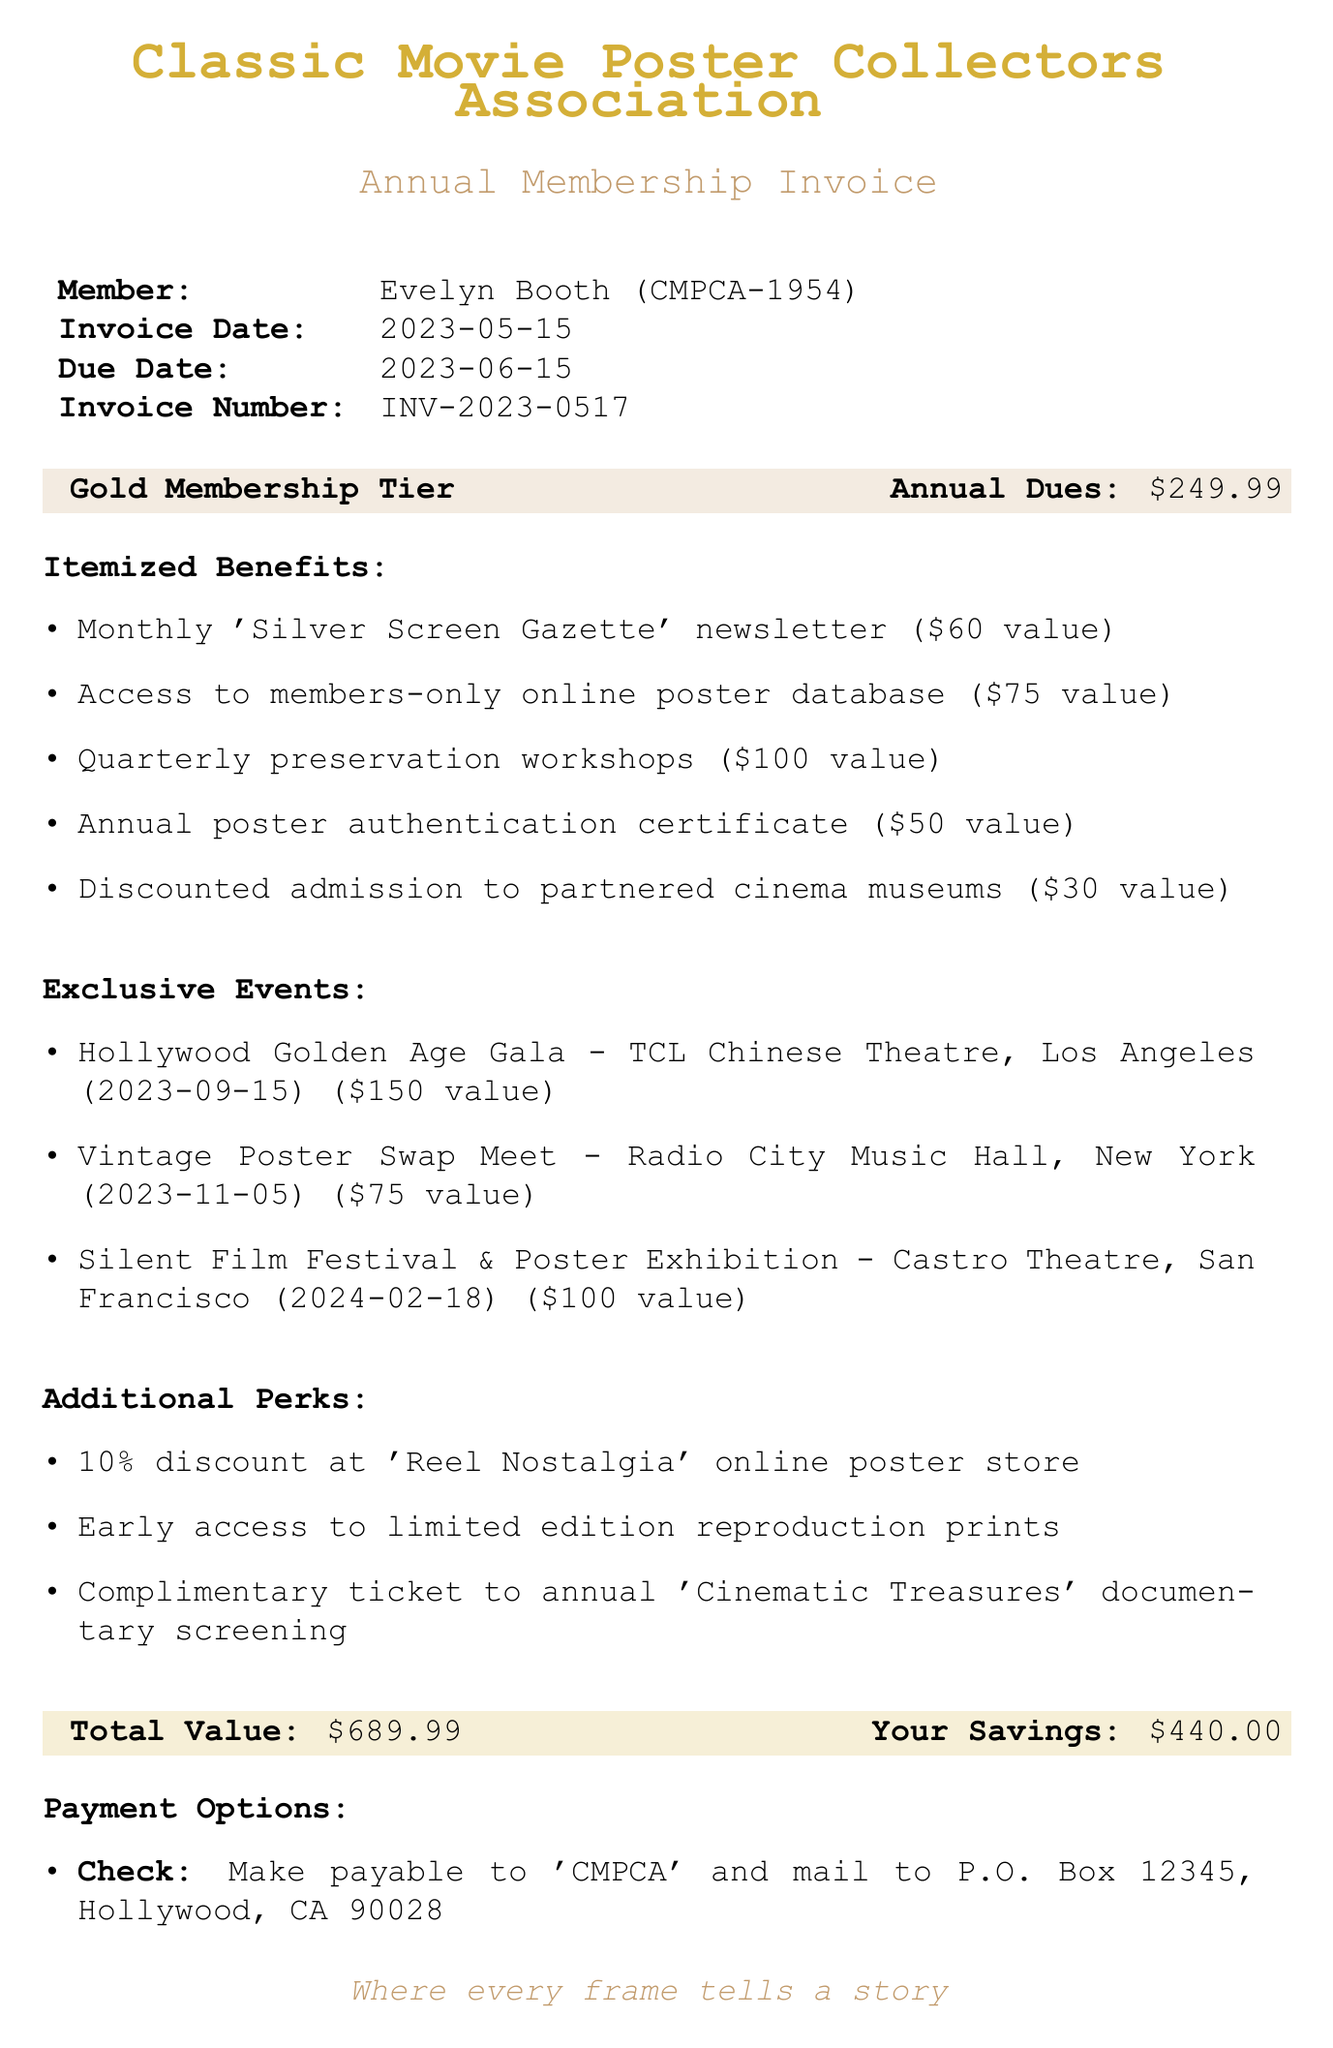What is the member name? The member name listed in the document is found next to the "Member:" label.
Answer: Evelyn Booth What is the membership tier? The membership tier information can be found in the section that highlights membership details.
Answer: Gold What is the total value of the invoice? The total value is specified in the section highlighting financial details.
Answer: $689.99 What is the due date for the invoice? The due date is provided under the invoice details section.
Answer: 2023-06-15 How many exclusive events are listed? The number of exclusive events can be determined by counting the items listed under the "Exclusive Events" section.
Answer: 3 What is the value of the "Quarterly preservation workshops" benefit? The value for this benefit is specified in the itemized benefits section.
Answer: $100 What additional perk offers a discount? The additional perk that offers a discount is specifically mentioned in the perks section.
Answer: 10% discount at 'Reel Nostalgia' online poster store How much is the annual poster authentication certificate valued at? The value of this certificate is detailed in the benefits section.
Answer: $50 What is the payment method for PayPal? The payment method instructions for PayPal are specified under the payment options section.
Answer: Send payment to treasurer@classicmovieposterassociation.org 